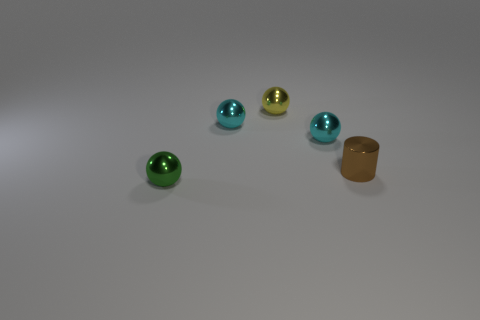Subtract all green spheres. How many spheres are left? 3 Subtract 1 cylinders. How many cylinders are left? 0 Subtract all cyan balls. How many balls are left? 2 Add 2 metal cylinders. How many objects exist? 7 Subtract all spheres. How many objects are left? 1 Subtract all small green balls. Subtract all large cyan matte blocks. How many objects are left? 4 Add 1 cylinders. How many cylinders are left? 2 Add 3 yellow balls. How many yellow balls exist? 4 Subtract 0 yellow cubes. How many objects are left? 5 Subtract all red cylinders. Subtract all yellow spheres. How many cylinders are left? 1 